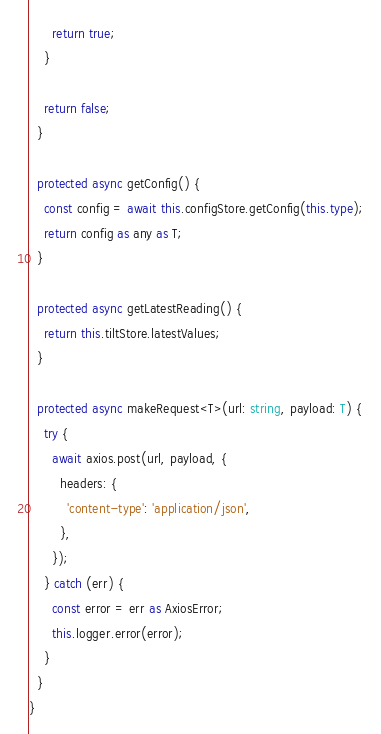Convert code to text. <code><loc_0><loc_0><loc_500><loc_500><_TypeScript_>      return true;
    }

    return false;
  }

  protected async getConfig() {
    const config = await this.configStore.getConfig(this.type);
    return config as any as T;
  }

  protected async getLatestReading() {
    return this.tiltStore.latestValues;
  }

  protected async makeRequest<T>(url: string, payload: T) {
    try {
      await axios.post(url, payload, {
        headers: {
          'content-type': 'application/json',
        },
      });
    } catch (err) {
      const error = err as AxiosError;
      this.logger.error(error);
    }
  }
}
</code> 